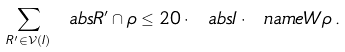<formula> <loc_0><loc_0><loc_500><loc_500>\sum _ { R ^ { \prime } \in \mathcal { V } ( I ) } \ a b s { R ^ { \prime } \cap \rho } \leq 2 0 \cdot \ a b s I \cdot \ n a m e W \rho \, .</formula> 